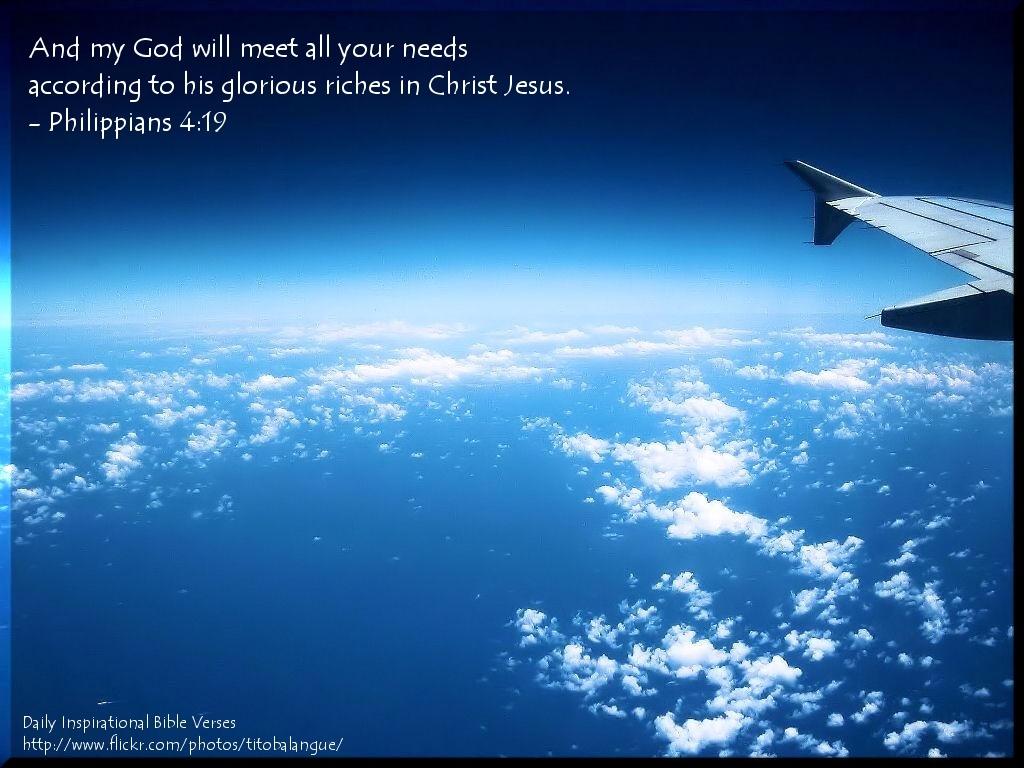Where exactly can i find this quote from the bible?
Offer a very short reply. Philippians 4:19. 